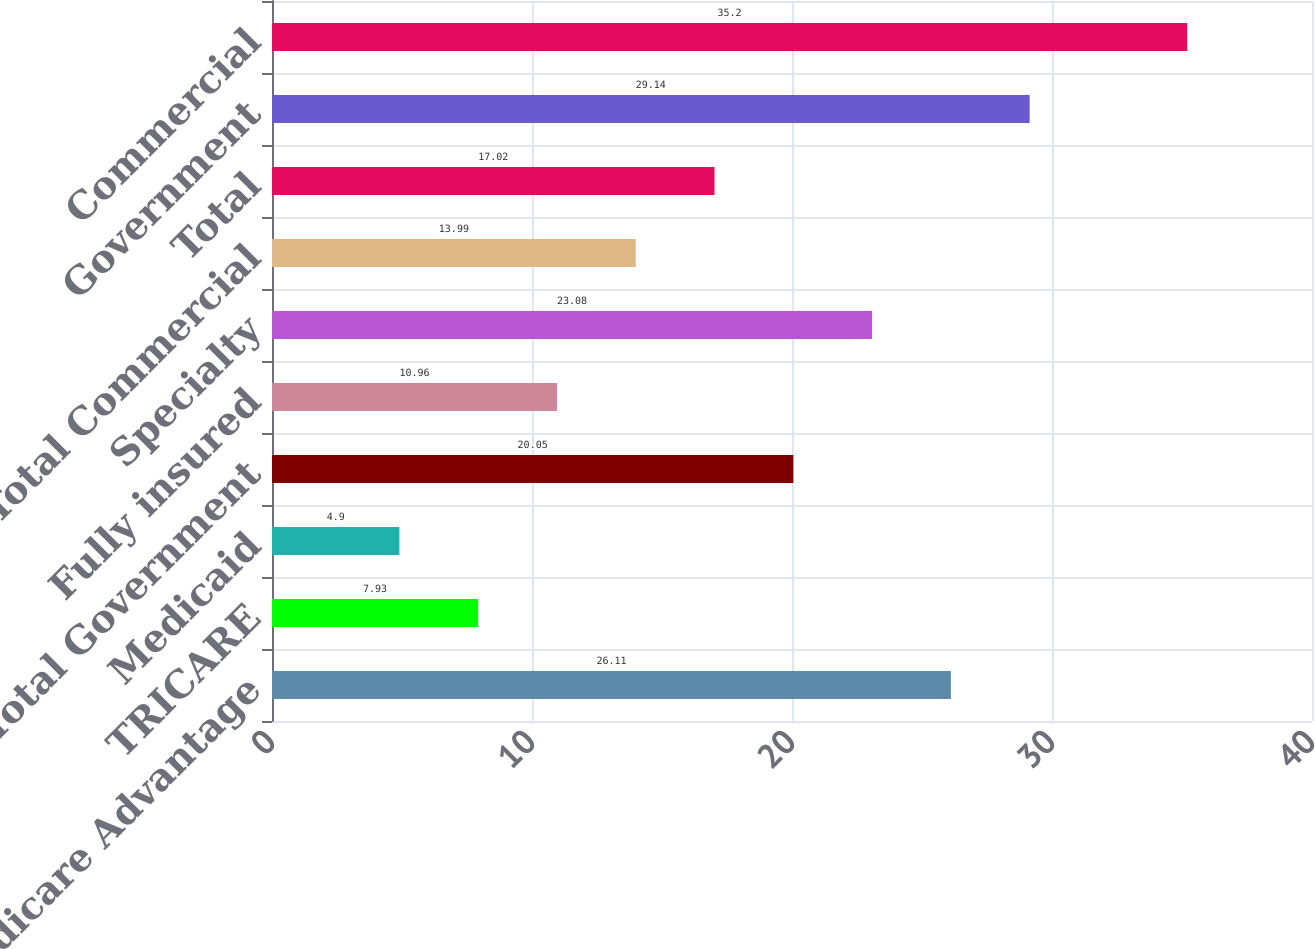Convert chart. <chart><loc_0><loc_0><loc_500><loc_500><bar_chart><fcel>Medicare Advantage<fcel>TRICARE<fcel>Medicaid<fcel>Total Government<fcel>Fully insured<fcel>Specialty<fcel>Total Commercial<fcel>Total<fcel>Government<fcel>Commercial<nl><fcel>26.11<fcel>7.93<fcel>4.9<fcel>20.05<fcel>10.96<fcel>23.08<fcel>13.99<fcel>17.02<fcel>29.14<fcel>35.2<nl></chart> 